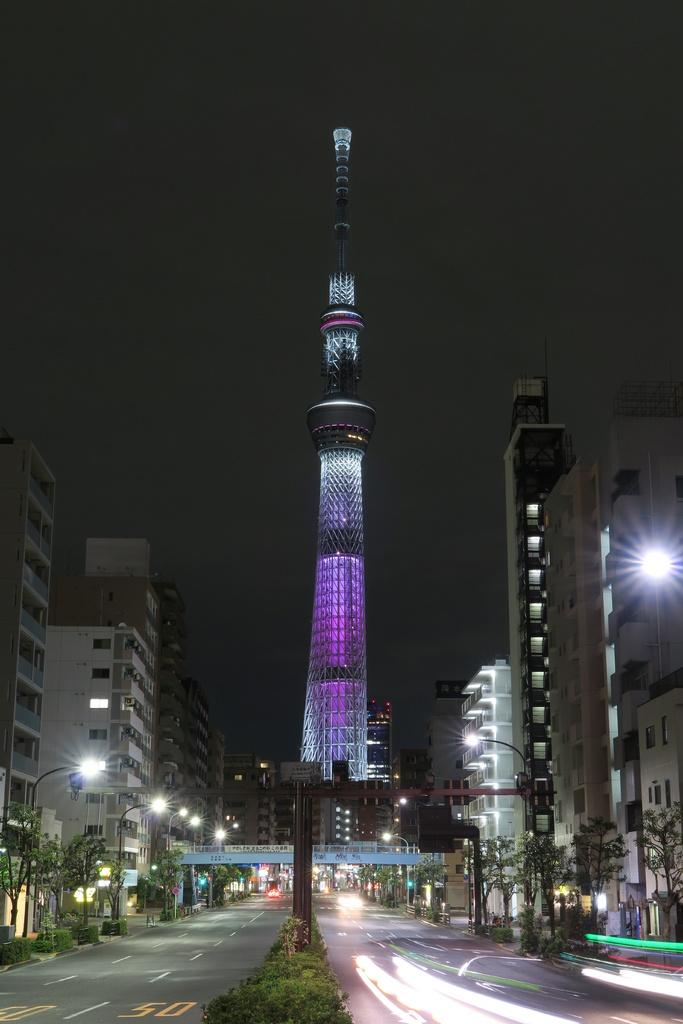What type of structures can be seen in the image? There are buildings in the image. What can be seen illuminating the scene in the image? There are lights and street lights in the image. What type of natural elements are present in the image? There are plants and trees in the image. What type of pathway is visible in the image? There is a road in the image. What type of transportation is present in the image? There are vehicles in the image. What part of the natural environment is visible in the image? The sky is visible in the image. What type of window can be seen in the image? There is no window present in the image. What type of shame can be seen on the vehicles in the image? There is no shame present in the image; it is not an emotion or feeling that can be seen on vehicles. 